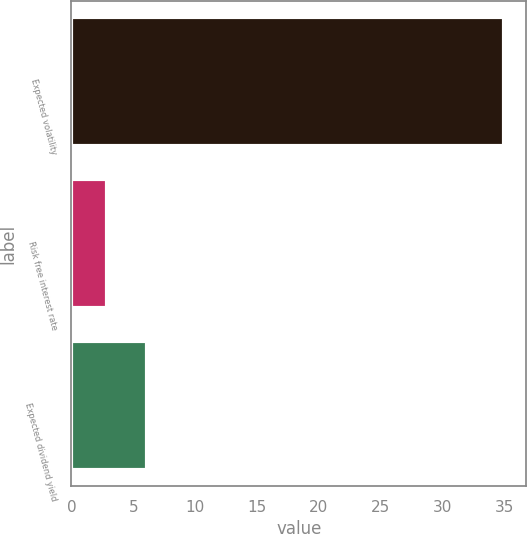Convert chart to OTSL. <chart><loc_0><loc_0><loc_500><loc_500><bar_chart><fcel>Expected volatility<fcel>Risk free interest rate<fcel>Expected dividend yield<nl><fcel>35<fcel>2.9<fcel>6.11<nl></chart> 